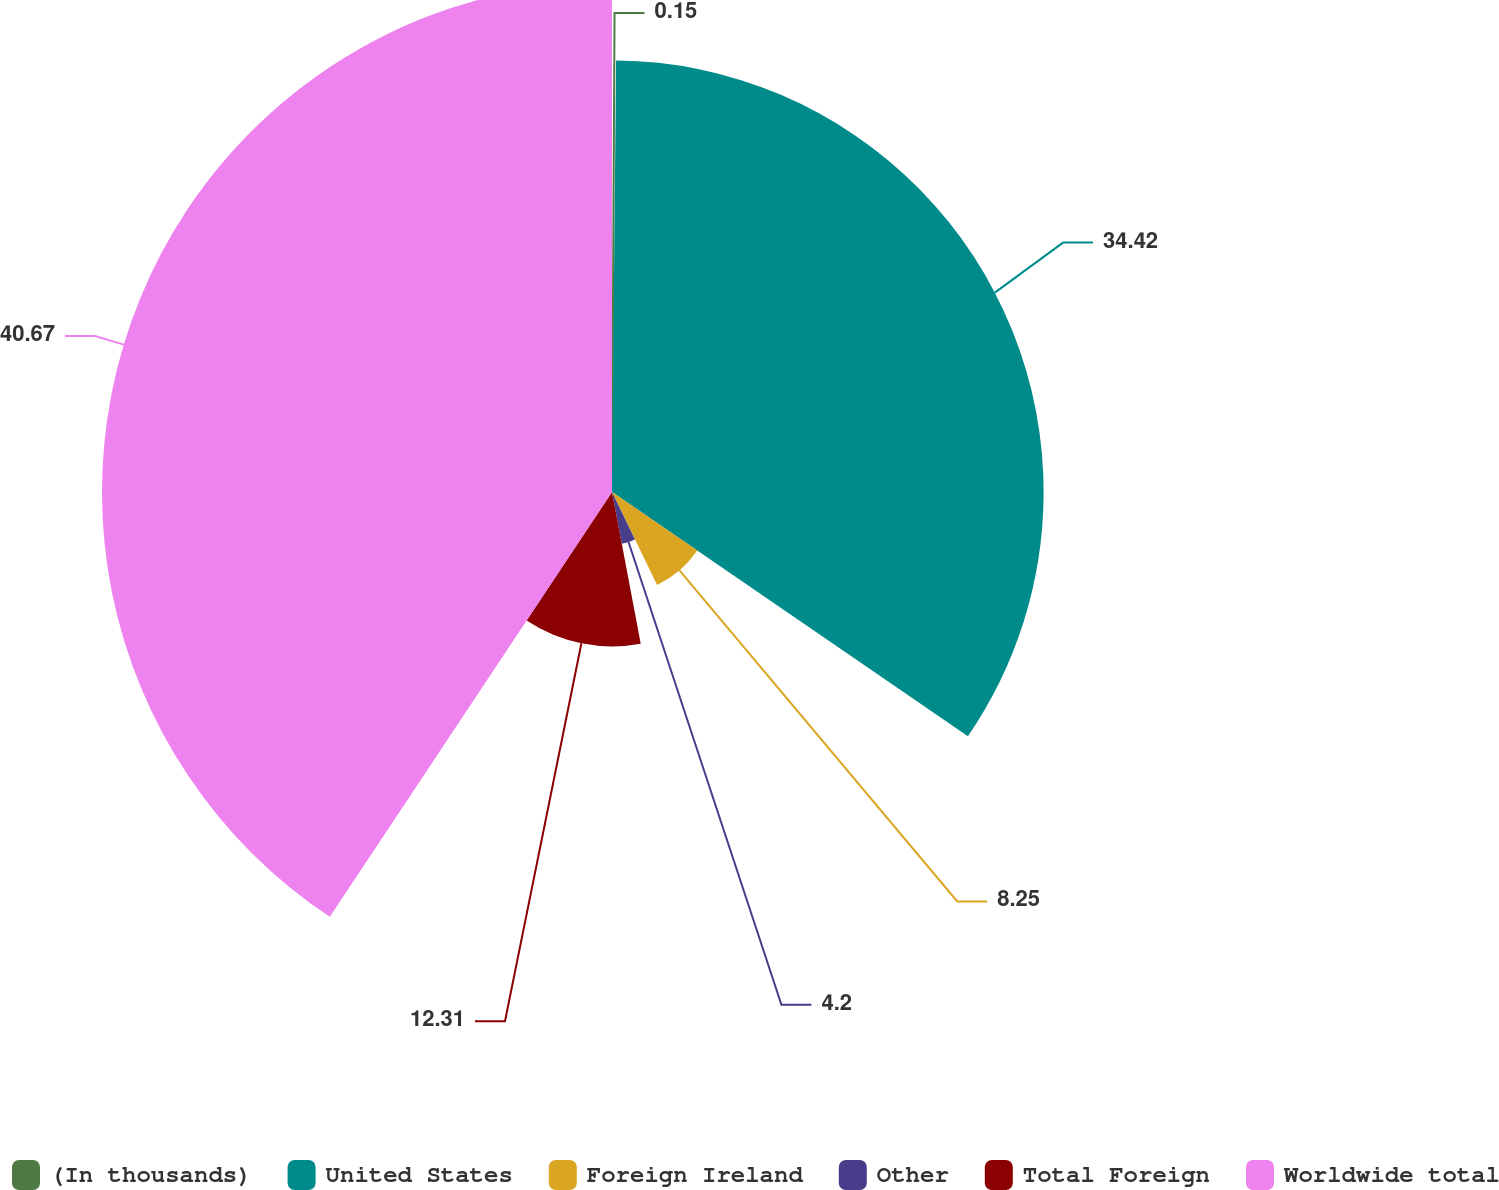<chart> <loc_0><loc_0><loc_500><loc_500><pie_chart><fcel>(In thousands)<fcel>United States<fcel>Foreign Ireland<fcel>Other<fcel>Total Foreign<fcel>Worldwide total<nl><fcel>0.15%<fcel>34.42%<fcel>8.25%<fcel>4.2%<fcel>12.31%<fcel>40.67%<nl></chart> 